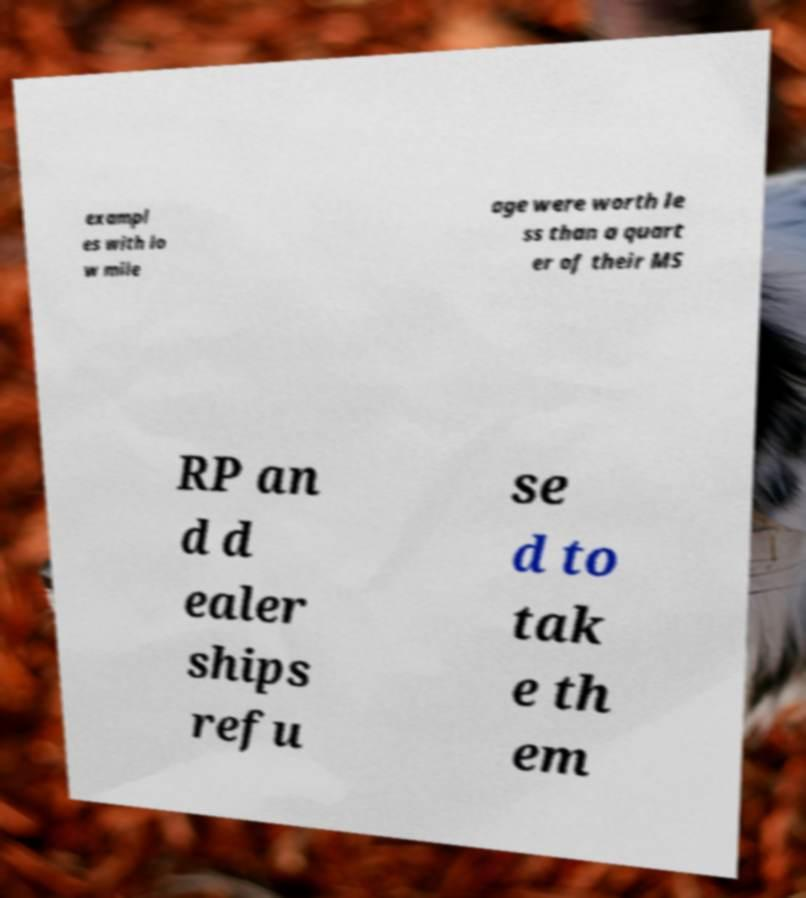There's text embedded in this image that I need extracted. Can you transcribe it verbatim? exampl es with lo w mile age were worth le ss than a quart er of their MS RP an d d ealer ships refu se d to tak e th em 